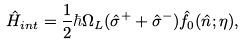Convert formula to latex. <formula><loc_0><loc_0><loc_500><loc_500>\hat { H } _ { i n t } = \frac { 1 } { 2 } \hbar { \Omega } _ { L } ( \hat { \sigma } ^ { + } + \hat { \sigma } ^ { - } ) \hat { f } _ { 0 } ( \hat { n } ; \eta ) ,</formula> 